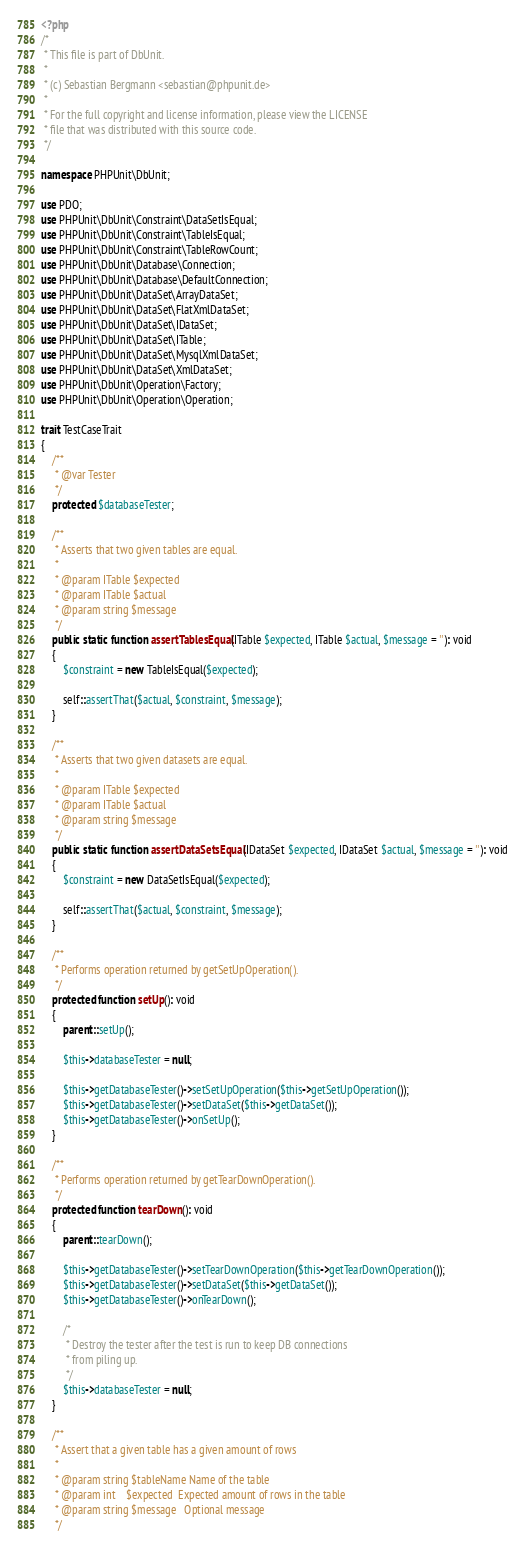Convert code to text. <code><loc_0><loc_0><loc_500><loc_500><_PHP_><?php
/*
 * This file is part of DbUnit.
 *
 * (c) Sebastian Bergmann <sebastian@phpunit.de>
 *
 * For the full copyright and license information, please view the LICENSE
 * file that was distributed with this source code.
 */

namespace PHPUnit\DbUnit;

use PDO;
use PHPUnit\DbUnit\Constraint\DataSetIsEqual;
use PHPUnit\DbUnit\Constraint\TableIsEqual;
use PHPUnit\DbUnit\Constraint\TableRowCount;
use PHPUnit\DbUnit\Database\Connection;
use PHPUnit\DbUnit\Database\DefaultConnection;
use PHPUnit\DbUnit\DataSet\ArrayDataSet;
use PHPUnit\DbUnit\DataSet\FlatXmlDataSet;
use PHPUnit\DbUnit\DataSet\IDataSet;
use PHPUnit\DbUnit\DataSet\ITable;
use PHPUnit\DbUnit\DataSet\MysqlXmlDataSet;
use PHPUnit\DbUnit\DataSet\XmlDataSet;
use PHPUnit\DbUnit\Operation\Factory;
use PHPUnit\DbUnit\Operation\Operation;

trait TestCaseTrait
{
    /**
     * @var Tester
     */
    protected $databaseTester;

    /**
     * Asserts that two given tables are equal.
     *
     * @param ITable $expected
     * @param ITable $actual
     * @param string $message
     */
    public static function assertTablesEqual(ITable $expected, ITable $actual, $message = ''): void
    {
        $constraint = new TableIsEqual($expected);

        self::assertThat($actual, $constraint, $message);
    }

    /**
     * Asserts that two given datasets are equal.
     *
     * @param ITable $expected
     * @param ITable $actual
     * @param string $message
     */
    public static function assertDataSetsEqual(IDataSet $expected, IDataSet $actual, $message = ''): void
    {
        $constraint = new DataSetIsEqual($expected);

        self::assertThat($actual, $constraint, $message);
    }

    /**
     * Performs operation returned by getSetUpOperation().
     */
    protected function setUp(): void
    {
        parent::setUp();

        $this->databaseTester = null;

        $this->getDatabaseTester()->setSetUpOperation($this->getSetUpOperation());
        $this->getDatabaseTester()->setDataSet($this->getDataSet());
        $this->getDatabaseTester()->onSetUp();
    }

    /**
     * Performs operation returned by getTearDownOperation().
     */
    protected function tearDown(): void
    {
        parent::tearDown();

        $this->getDatabaseTester()->setTearDownOperation($this->getTearDownOperation());
        $this->getDatabaseTester()->setDataSet($this->getDataSet());
        $this->getDatabaseTester()->onTearDown();

        /*
         * Destroy the tester after the test is run to keep DB connections
         * from piling up.
         */
        $this->databaseTester = null;
    }

    /**
     * Assert that a given table has a given amount of rows
     *
     * @param string $tableName Name of the table
     * @param int    $expected  Expected amount of rows in the table
     * @param string $message   Optional message
     */</code> 